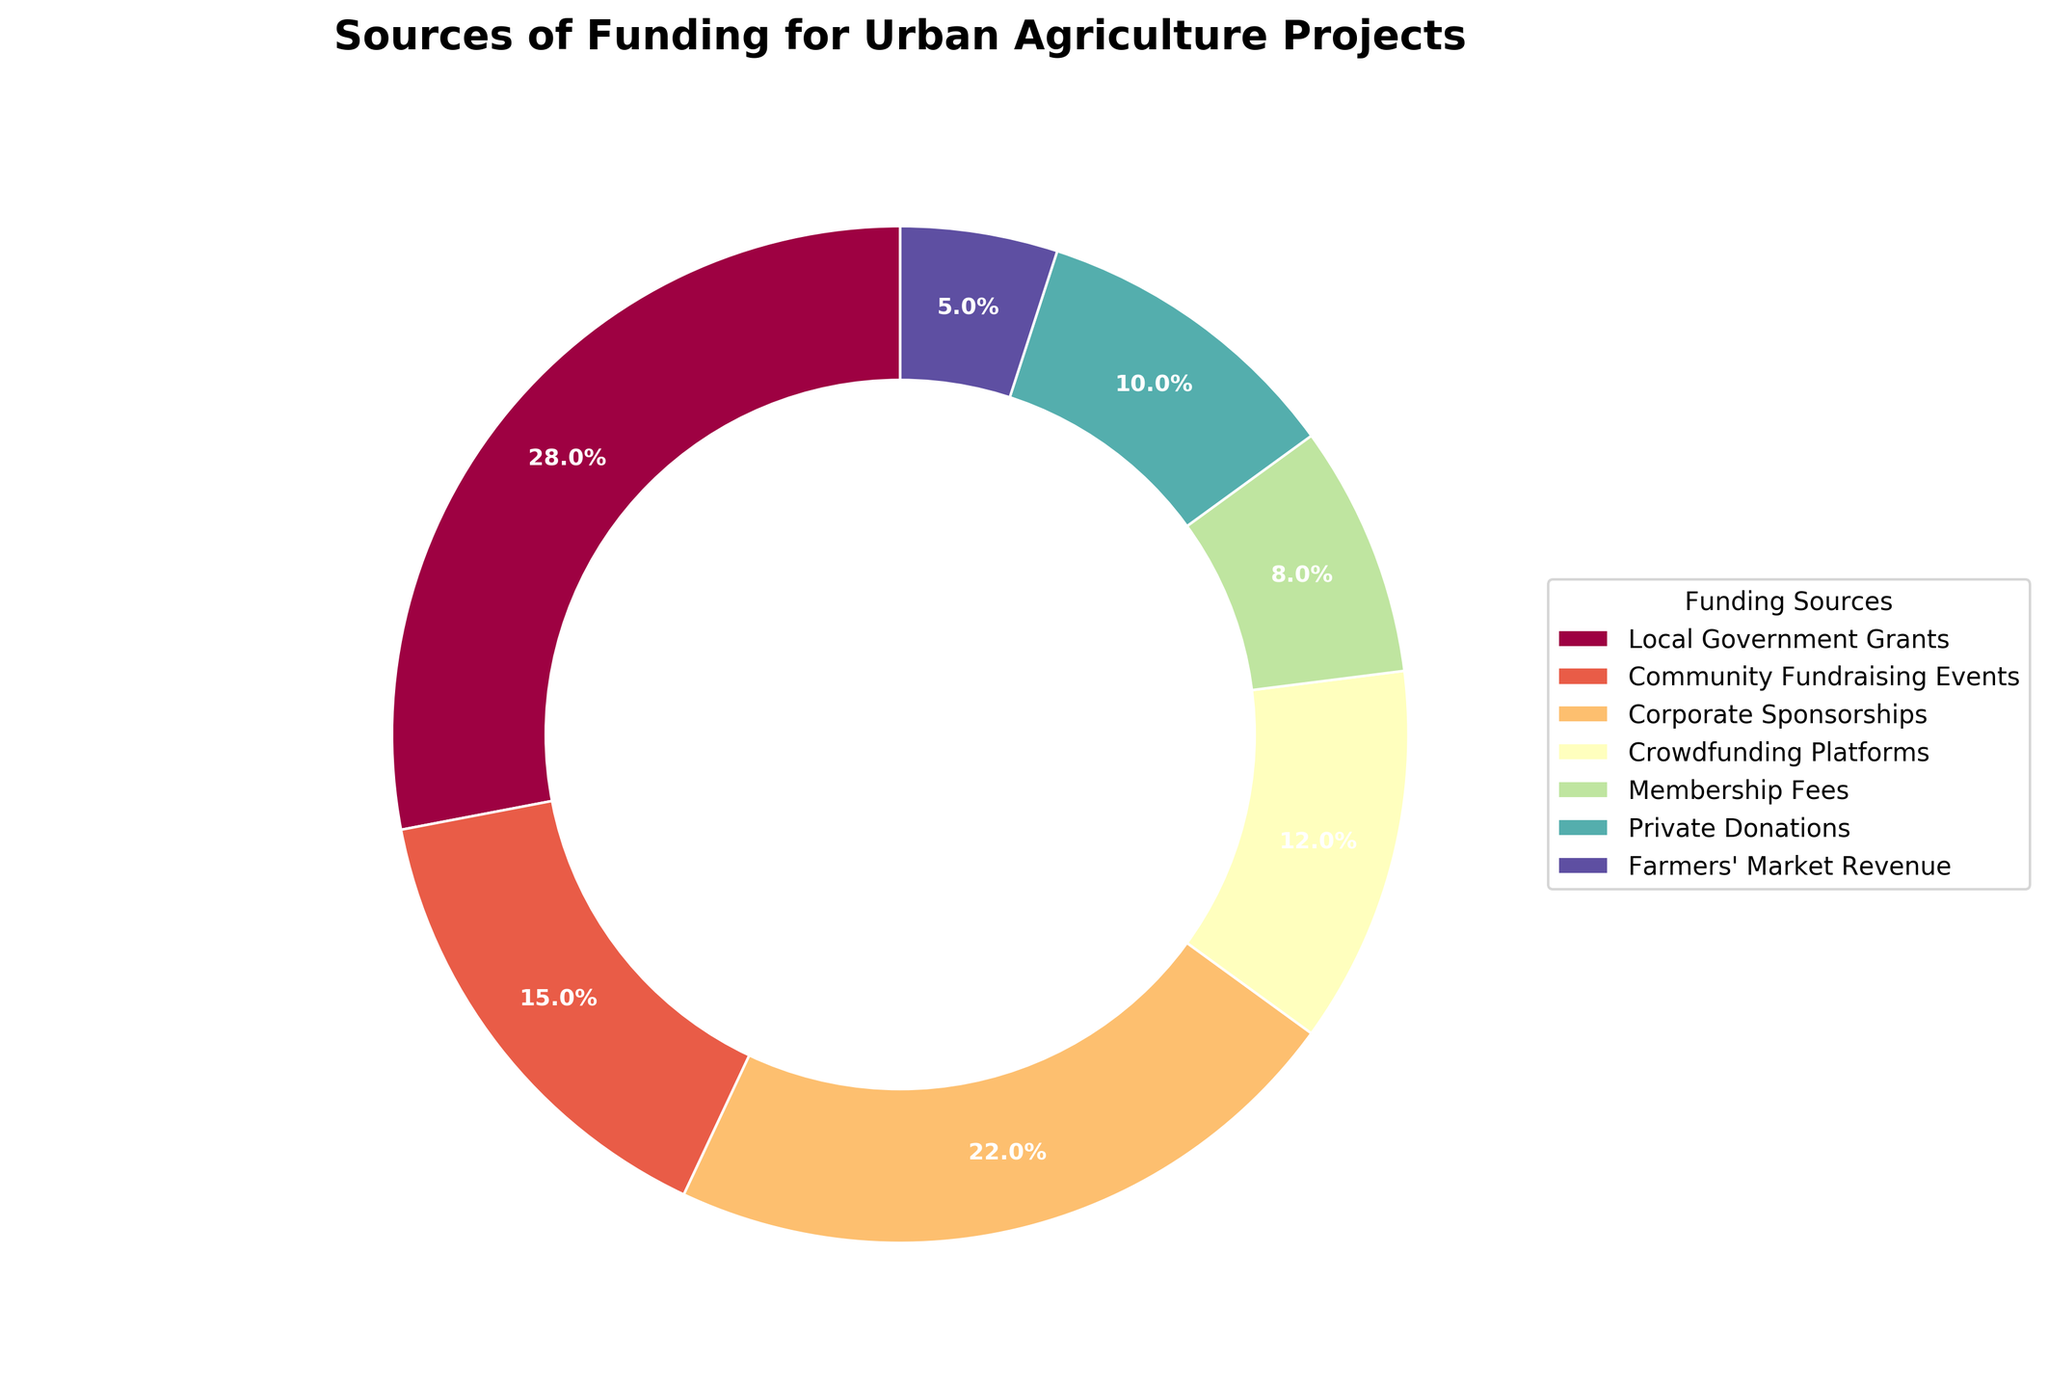Which funding source contributes the most to urban agriculture projects? The figure shows that "Local Government Grants" have the largest segment of the pie chart. So "Local Government Grants" contribute the most.
Answer: Local Government Grants Which funding source has the smallest contribution to urban agriculture projects? By looking at the figure, "Farmers' Market Revenue" has the smallest slice in the pie chart.
Answer: Farmers' Market Revenue What is the combined contribution of Corporate Sponsorships and Private Donations? From the figure, Corporate Sponsorships contribute 22% and Private Donations contribute 10%. Adding them together gives 22% + 10% = 32%.
Answer: 32% How much greater is the contribution from Local Government Grants compared to the combination of Crowdfunding Platforms and Membership Fees? Local Government Grants contribute 28%. Crowdfunding Platforms and Membership Fees contribute 12% and 8% respectively. Combined, they contribute 12% + 8% = 20%. The difference is 28% - 20% = 8%.
Answer: 8% Which two funding sources together account for exactly half of the total funding? By analyzing the figure, we see that "Local Government Grants" and "Corporate Sponsorships" together make up 28% + 22% = 50%.
Answer: Local Government Grants and Corporate Sponsorships How does the contribution from Community Fundraising Events compare to that from Crowdfunding Platforms? Community Fundraising Events contribute 15%, whereas Crowdfunding Platforms contribute 12%. Since 15% is greater than 12%, Community Fundraising Events contribute more.
Answer: Community Fundraising Events contribute more Which color represents Private Donations in the pie chart? As shown in the figure, each segment of the pie chart has a distinct color. The legend in the chart links the "Private Donations" segment to a specific color.
Answer: (depends on the chart – use the color name provided) What is the total contribution percentage of all funding sources except Private Donations and Farmers' Market Revenue? Excluding Private Donations (10%) and Farmers' Market Revenue (5%), we add the rest: 28% (Local Government Grants) + 15% (Community Fundraising Events) + 22% (Corporate Sponsorships) + 12% (Crowdfunding Platforms) + 8% (Membership Fees) = 85%.
Answer: 85% Which funding source is represented by the segment closest to the top of the pie chart? The top segment of the pie chart is at the 90-degree start angle, thus representing the beginning point in the chart, which can be identified from the visual.
Answer: (depends on the chart – use the label provided) 